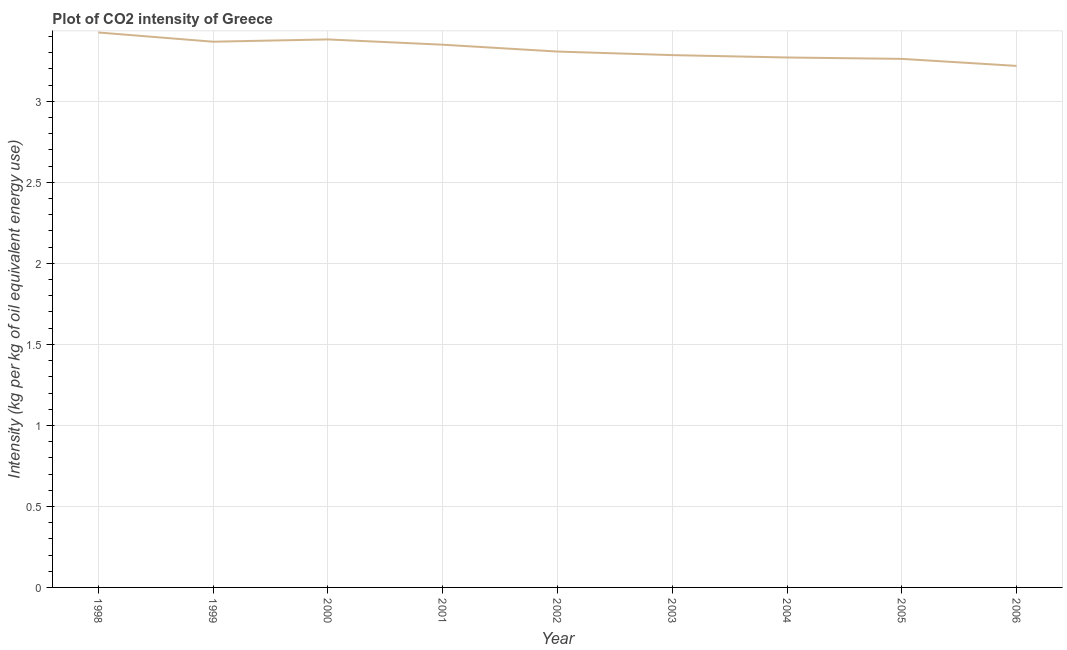What is the co2 intensity in 1998?
Your answer should be very brief. 3.43. Across all years, what is the maximum co2 intensity?
Offer a terse response. 3.43. Across all years, what is the minimum co2 intensity?
Your response must be concise. 3.22. What is the sum of the co2 intensity?
Your answer should be very brief. 29.87. What is the difference between the co2 intensity in 1999 and 2006?
Provide a short and direct response. 0.15. What is the average co2 intensity per year?
Provide a short and direct response. 3.32. What is the median co2 intensity?
Offer a terse response. 3.31. Do a majority of the years between 1999 and 2004 (inclusive) have co2 intensity greater than 1.3 kg?
Your answer should be compact. Yes. What is the ratio of the co2 intensity in 2002 to that in 2004?
Provide a short and direct response. 1.01. What is the difference between the highest and the second highest co2 intensity?
Provide a succinct answer. 0.04. Is the sum of the co2 intensity in 2003 and 2004 greater than the maximum co2 intensity across all years?
Your answer should be compact. Yes. What is the difference between the highest and the lowest co2 intensity?
Your answer should be compact. 0.21. Does the co2 intensity monotonically increase over the years?
Offer a terse response. No. How many lines are there?
Offer a very short reply. 1. Are the values on the major ticks of Y-axis written in scientific E-notation?
Keep it short and to the point. No. Does the graph contain grids?
Ensure brevity in your answer.  Yes. What is the title of the graph?
Your answer should be very brief. Plot of CO2 intensity of Greece. What is the label or title of the X-axis?
Your answer should be compact. Year. What is the label or title of the Y-axis?
Your response must be concise. Intensity (kg per kg of oil equivalent energy use). What is the Intensity (kg per kg of oil equivalent energy use) of 1998?
Offer a terse response. 3.43. What is the Intensity (kg per kg of oil equivalent energy use) of 1999?
Provide a short and direct response. 3.37. What is the Intensity (kg per kg of oil equivalent energy use) in 2000?
Your answer should be compact. 3.38. What is the Intensity (kg per kg of oil equivalent energy use) in 2001?
Your response must be concise. 3.35. What is the Intensity (kg per kg of oil equivalent energy use) of 2002?
Provide a short and direct response. 3.31. What is the Intensity (kg per kg of oil equivalent energy use) in 2003?
Keep it short and to the point. 3.29. What is the Intensity (kg per kg of oil equivalent energy use) of 2004?
Provide a short and direct response. 3.27. What is the Intensity (kg per kg of oil equivalent energy use) of 2005?
Your response must be concise. 3.26. What is the Intensity (kg per kg of oil equivalent energy use) of 2006?
Offer a terse response. 3.22. What is the difference between the Intensity (kg per kg of oil equivalent energy use) in 1998 and 1999?
Keep it short and to the point. 0.06. What is the difference between the Intensity (kg per kg of oil equivalent energy use) in 1998 and 2000?
Make the answer very short. 0.04. What is the difference between the Intensity (kg per kg of oil equivalent energy use) in 1998 and 2001?
Keep it short and to the point. 0.08. What is the difference between the Intensity (kg per kg of oil equivalent energy use) in 1998 and 2002?
Your answer should be compact. 0.12. What is the difference between the Intensity (kg per kg of oil equivalent energy use) in 1998 and 2003?
Your answer should be compact. 0.14. What is the difference between the Intensity (kg per kg of oil equivalent energy use) in 1998 and 2004?
Your answer should be compact. 0.15. What is the difference between the Intensity (kg per kg of oil equivalent energy use) in 1998 and 2005?
Offer a terse response. 0.16. What is the difference between the Intensity (kg per kg of oil equivalent energy use) in 1998 and 2006?
Provide a short and direct response. 0.21. What is the difference between the Intensity (kg per kg of oil equivalent energy use) in 1999 and 2000?
Provide a succinct answer. -0.01. What is the difference between the Intensity (kg per kg of oil equivalent energy use) in 1999 and 2001?
Offer a terse response. 0.02. What is the difference between the Intensity (kg per kg of oil equivalent energy use) in 1999 and 2002?
Your response must be concise. 0.06. What is the difference between the Intensity (kg per kg of oil equivalent energy use) in 1999 and 2003?
Ensure brevity in your answer.  0.08. What is the difference between the Intensity (kg per kg of oil equivalent energy use) in 1999 and 2004?
Provide a succinct answer. 0.1. What is the difference between the Intensity (kg per kg of oil equivalent energy use) in 1999 and 2005?
Offer a very short reply. 0.11. What is the difference between the Intensity (kg per kg of oil equivalent energy use) in 1999 and 2006?
Make the answer very short. 0.15. What is the difference between the Intensity (kg per kg of oil equivalent energy use) in 2000 and 2001?
Give a very brief answer. 0.03. What is the difference between the Intensity (kg per kg of oil equivalent energy use) in 2000 and 2002?
Make the answer very short. 0.07. What is the difference between the Intensity (kg per kg of oil equivalent energy use) in 2000 and 2003?
Offer a terse response. 0.1. What is the difference between the Intensity (kg per kg of oil equivalent energy use) in 2000 and 2004?
Keep it short and to the point. 0.11. What is the difference between the Intensity (kg per kg of oil equivalent energy use) in 2000 and 2005?
Provide a short and direct response. 0.12. What is the difference between the Intensity (kg per kg of oil equivalent energy use) in 2000 and 2006?
Provide a succinct answer. 0.16. What is the difference between the Intensity (kg per kg of oil equivalent energy use) in 2001 and 2002?
Your answer should be compact. 0.04. What is the difference between the Intensity (kg per kg of oil equivalent energy use) in 2001 and 2003?
Provide a short and direct response. 0.06. What is the difference between the Intensity (kg per kg of oil equivalent energy use) in 2001 and 2004?
Keep it short and to the point. 0.08. What is the difference between the Intensity (kg per kg of oil equivalent energy use) in 2001 and 2005?
Offer a terse response. 0.09. What is the difference between the Intensity (kg per kg of oil equivalent energy use) in 2001 and 2006?
Make the answer very short. 0.13. What is the difference between the Intensity (kg per kg of oil equivalent energy use) in 2002 and 2003?
Your response must be concise. 0.02. What is the difference between the Intensity (kg per kg of oil equivalent energy use) in 2002 and 2004?
Your answer should be compact. 0.04. What is the difference between the Intensity (kg per kg of oil equivalent energy use) in 2002 and 2005?
Make the answer very short. 0.05. What is the difference between the Intensity (kg per kg of oil equivalent energy use) in 2002 and 2006?
Offer a very short reply. 0.09. What is the difference between the Intensity (kg per kg of oil equivalent energy use) in 2003 and 2004?
Give a very brief answer. 0.01. What is the difference between the Intensity (kg per kg of oil equivalent energy use) in 2003 and 2005?
Your answer should be very brief. 0.02. What is the difference between the Intensity (kg per kg of oil equivalent energy use) in 2003 and 2006?
Ensure brevity in your answer.  0.07. What is the difference between the Intensity (kg per kg of oil equivalent energy use) in 2004 and 2005?
Your answer should be compact. 0.01. What is the difference between the Intensity (kg per kg of oil equivalent energy use) in 2004 and 2006?
Provide a short and direct response. 0.05. What is the difference between the Intensity (kg per kg of oil equivalent energy use) in 2005 and 2006?
Make the answer very short. 0.04. What is the ratio of the Intensity (kg per kg of oil equivalent energy use) in 1998 to that in 2000?
Keep it short and to the point. 1.01. What is the ratio of the Intensity (kg per kg of oil equivalent energy use) in 1998 to that in 2002?
Your response must be concise. 1.04. What is the ratio of the Intensity (kg per kg of oil equivalent energy use) in 1998 to that in 2003?
Your answer should be very brief. 1.04. What is the ratio of the Intensity (kg per kg of oil equivalent energy use) in 1998 to that in 2004?
Offer a terse response. 1.05. What is the ratio of the Intensity (kg per kg of oil equivalent energy use) in 1998 to that in 2006?
Make the answer very short. 1.06. What is the ratio of the Intensity (kg per kg of oil equivalent energy use) in 1999 to that in 2000?
Provide a short and direct response. 1. What is the ratio of the Intensity (kg per kg of oil equivalent energy use) in 1999 to that in 2001?
Your response must be concise. 1.01. What is the ratio of the Intensity (kg per kg of oil equivalent energy use) in 1999 to that in 2002?
Your answer should be very brief. 1.02. What is the ratio of the Intensity (kg per kg of oil equivalent energy use) in 1999 to that in 2003?
Offer a very short reply. 1.02. What is the ratio of the Intensity (kg per kg of oil equivalent energy use) in 1999 to that in 2004?
Ensure brevity in your answer.  1.03. What is the ratio of the Intensity (kg per kg of oil equivalent energy use) in 1999 to that in 2005?
Offer a very short reply. 1.03. What is the ratio of the Intensity (kg per kg of oil equivalent energy use) in 1999 to that in 2006?
Provide a succinct answer. 1.05. What is the ratio of the Intensity (kg per kg of oil equivalent energy use) in 2000 to that in 2002?
Make the answer very short. 1.02. What is the ratio of the Intensity (kg per kg of oil equivalent energy use) in 2000 to that in 2004?
Your answer should be very brief. 1.03. What is the ratio of the Intensity (kg per kg of oil equivalent energy use) in 2000 to that in 2005?
Offer a very short reply. 1.04. What is the ratio of the Intensity (kg per kg of oil equivalent energy use) in 2000 to that in 2006?
Ensure brevity in your answer.  1.05. What is the ratio of the Intensity (kg per kg of oil equivalent energy use) in 2001 to that in 2003?
Provide a short and direct response. 1.02. What is the ratio of the Intensity (kg per kg of oil equivalent energy use) in 2001 to that in 2005?
Your answer should be very brief. 1.03. What is the ratio of the Intensity (kg per kg of oil equivalent energy use) in 2001 to that in 2006?
Your answer should be compact. 1.04. What is the ratio of the Intensity (kg per kg of oil equivalent energy use) in 2002 to that in 2003?
Offer a terse response. 1.01. What is the ratio of the Intensity (kg per kg of oil equivalent energy use) in 2002 to that in 2005?
Your response must be concise. 1.01. What is the ratio of the Intensity (kg per kg of oil equivalent energy use) in 2002 to that in 2006?
Make the answer very short. 1.03. What is the ratio of the Intensity (kg per kg of oil equivalent energy use) in 2003 to that in 2005?
Ensure brevity in your answer.  1.01. What is the ratio of the Intensity (kg per kg of oil equivalent energy use) in 2004 to that in 2006?
Offer a terse response. 1.02. What is the ratio of the Intensity (kg per kg of oil equivalent energy use) in 2005 to that in 2006?
Make the answer very short. 1.01. 